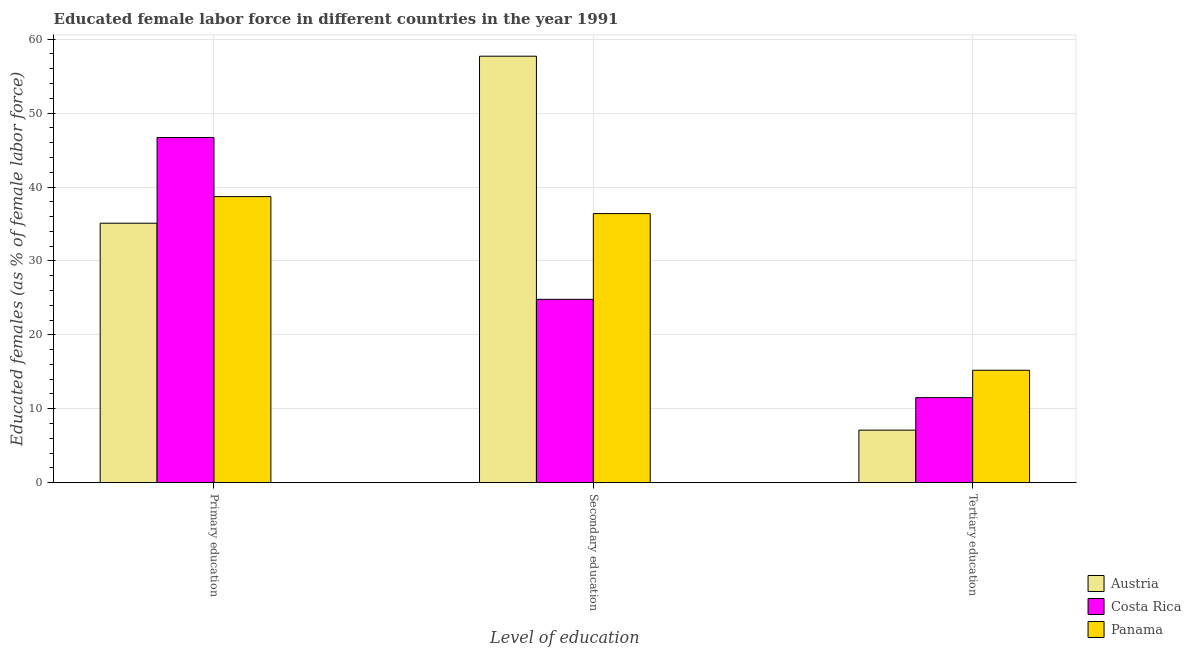How many different coloured bars are there?
Your answer should be very brief. 3. How many groups of bars are there?
Offer a very short reply. 3. Are the number of bars per tick equal to the number of legend labels?
Provide a succinct answer. Yes. Are the number of bars on each tick of the X-axis equal?
Ensure brevity in your answer.  Yes. How many bars are there on the 3rd tick from the right?
Keep it short and to the point. 3. What is the label of the 1st group of bars from the left?
Give a very brief answer. Primary education. What is the percentage of female labor force who received secondary education in Austria?
Ensure brevity in your answer.  57.7. Across all countries, what is the maximum percentage of female labor force who received secondary education?
Ensure brevity in your answer.  57.7. Across all countries, what is the minimum percentage of female labor force who received primary education?
Make the answer very short. 35.1. In which country was the percentage of female labor force who received secondary education maximum?
Your answer should be compact. Austria. What is the total percentage of female labor force who received tertiary education in the graph?
Your answer should be compact. 33.8. What is the difference between the percentage of female labor force who received secondary education in Panama and that in Austria?
Ensure brevity in your answer.  -21.3. What is the difference between the percentage of female labor force who received tertiary education in Austria and the percentage of female labor force who received primary education in Panama?
Offer a terse response. -31.6. What is the average percentage of female labor force who received primary education per country?
Make the answer very short. 40.17. What is the difference between the percentage of female labor force who received tertiary education and percentage of female labor force who received secondary education in Costa Rica?
Give a very brief answer. -13.3. In how many countries, is the percentage of female labor force who received primary education greater than 54 %?
Your response must be concise. 0. What is the ratio of the percentage of female labor force who received primary education in Austria to that in Costa Rica?
Offer a terse response. 0.75. What is the difference between the highest and the second highest percentage of female labor force who received secondary education?
Provide a short and direct response. 21.3. What is the difference between the highest and the lowest percentage of female labor force who received secondary education?
Make the answer very short. 32.9. What does the 1st bar from the right in Primary education represents?
Give a very brief answer. Panama. Are the values on the major ticks of Y-axis written in scientific E-notation?
Your response must be concise. No. Does the graph contain grids?
Provide a short and direct response. Yes. Where does the legend appear in the graph?
Your answer should be very brief. Bottom right. How are the legend labels stacked?
Give a very brief answer. Vertical. What is the title of the graph?
Give a very brief answer. Educated female labor force in different countries in the year 1991. What is the label or title of the X-axis?
Give a very brief answer. Level of education. What is the label or title of the Y-axis?
Give a very brief answer. Educated females (as % of female labor force). What is the Educated females (as % of female labor force) of Austria in Primary education?
Ensure brevity in your answer.  35.1. What is the Educated females (as % of female labor force) in Costa Rica in Primary education?
Provide a short and direct response. 46.7. What is the Educated females (as % of female labor force) of Panama in Primary education?
Keep it short and to the point. 38.7. What is the Educated females (as % of female labor force) in Austria in Secondary education?
Provide a succinct answer. 57.7. What is the Educated females (as % of female labor force) in Costa Rica in Secondary education?
Offer a terse response. 24.8. What is the Educated females (as % of female labor force) of Panama in Secondary education?
Provide a short and direct response. 36.4. What is the Educated females (as % of female labor force) in Austria in Tertiary education?
Provide a succinct answer. 7.1. What is the Educated females (as % of female labor force) of Panama in Tertiary education?
Ensure brevity in your answer.  15.2. Across all Level of education, what is the maximum Educated females (as % of female labor force) in Austria?
Ensure brevity in your answer.  57.7. Across all Level of education, what is the maximum Educated females (as % of female labor force) of Costa Rica?
Ensure brevity in your answer.  46.7. Across all Level of education, what is the maximum Educated females (as % of female labor force) of Panama?
Give a very brief answer. 38.7. Across all Level of education, what is the minimum Educated females (as % of female labor force) of Austria?
Your answer should be compact. 7.1. Across all Level of education, what is the minimum Educated females (as % of female labor force) of Costa Rica?
Ensure brevity in your answer.  11.5. Across all Level of education, what is the minimum Educated females (as % of female labor force) of Panama?
Your answer should be very brief. 15.2. What is the total Educated females (as % of female labor force) of Austria in the graph?
Ensure brevity in your answer.  99.9. What is the total Educated females (as % of female labor force) of Panama in the graph?
Provide a short and direct response. 90.3. What is the difference between the Educated females (as % of female labor force) of Austria in Primary education and that in Secondary education?
Ensure brevity in your answer.  -22.6. What is the difference between the Educated females (as % of female labor force) of Costa Rica in Primary education and that in Secondary education?
Provide a succinct answer. 21.9. What is the difference between the Educated females (as % of female labor force) of Panama in Primary education and that in Secondary education?
Offer a terse response. 2.3. What is the difference between the Educated females (as % of female labor force) in Costa Rica in Primary education and that in Tertiary education?
Offer a very short reply. 35.2. What is the difference between the Educated females (as % of female labor force) in Panama in Primary education and that in Tertiary education?
Ensure brevity in your answer.  23.5. What is the difference between the Educated females (as % of female labor force) of Austria in Secondary education and that in Tertiary education?
Your response must be concise. 50.6. What is the difference between the Educated females (as % of female labor force) of Costa Rica in Secondary education and that in Tertiary education?
Provide a succinct answer. 13.3. What is the difference between the Educated females (as % of female labor force) in Panama in Secondary education and that in Tertiary education?
Provide a succinct answer. 21.2. What is the difference between the Educated females (as % of female labor force) of Austria in Primary education and the Educated females (as % of female labor force) of Costa Rica in Secondary education?
Offer a very short reply. 10.3. What is the difference between the Educated females (as % of female labor force) of Austria in Primary education and the Educated females (as % of female labor force) of Costa Rica in Tertiary education?
Provide a succinct answer. 23.6. What is the difference between the Educated females (as % of female labor force) of Costa Rica in Primary education and the Educated females (as % of female labor force) of Panama in Tertiary education?
Give a very brief answer. 31.5. What is the difference between the Educated females (as % of female labor force) in Austria in Secondary education and the Educated females (as % of female labor force) in Costa Rica in Tertiary education?
Your answer should be very brief. 46.2. What is the difference between the Educated females (as % of female labor force) of Austria in Secondary education and the Educated females (as % of female labor force) of Panama in Tertiary education?
Offer a terse response. 42.5. What is the average Educated females (as % of female labor force) in Austria per Level of education?
Ensure brevity in your answer.  33.3. What is the average Educated females (as % of female labor force) in Costa Rica per Level of education?
Provide a short and direct response. 27.67. What is the average Educated females (as % of female labor force) of Panama per Level of education?
Provide a succinct answer. 30.1. What is the difference between the Educated females (as % of female labor force) of Austria and Educated females (as % of female labor force) of Costa Rica in Primary education?
Your answer should be compact. -11.6. What is the difference between the Educated females (as % of female labor force) in Costa Rica and Educated females (as % of female labor force) in Panama in Primary education?
Offer a terse response. 8. What is the difference between the Educated females (as % of female labor force) in Austria and Educated females (as % of female labor force) in Costa Rica in Secondary education?
Offer a very short reply. 32.9. What is the difference between the Educated females (as % of female labor force) of Austria and Educated females (as % of female labor force) of Panama in Secondary education?
Offer a very short reply. 21.3. What is the difference between the Educated females (as % of female labor force) in Costa Rica and Educated females (as % of female labor force) in Panama in Secondary education?
Your answer should be compact. -11.6. What is the difference between the Educated females (as % of female labor force) in Austria and Educated females (as % of female labor force) in Panama in Tertiary education?
Keep it short and to the point. -8.1. What is the ratio of the Educated females (as % of female labor force) of Austria in Primary education to that in Secondary education?
Offer a very short reply. 0.61. What is the ratio of the Educated females (as % of female labor force) in Costa Rica in Primary education to that in Secondary education?
Your answer should be very brief. 1.88. What is the ratio of the Educated females (as % of female labor force) in Panama in Primary education to that in Secondary education?
Your response must be concise. 1.06. What is the ratio of the Educated females (as % of female labor force) of Austria in Primary education to that in Tertiary education?
Your answer should be compact. 4.94. What is the ratio of the Educated females (as % of female labor force) in Costa Rica in Primary education to that in Tertiary education?
Give a very brief answer. 4.06. What is the ratio of the Educated females (as % of female labor force) in Panama in Primary education to that in Tertiary education?
Your response must be concise. 2.55. What is the ratio of the Educated females (as % of female labor force) of Austria in Secondary education to that in Tertiary education?
Make the answer very short. 8.13. What is the ratio of the Educated females (as % of female labor force) of Costa Rica in Secondary education to that in Tertiary education?
Provide a short and direct response. 2.16. What is the ratio of the Educated females (as % of female labor force) of Panama in Secondary education to that in Tertiary education?
Your response must be concise. 2.39. What is the difference between the highest and the second highest Educated females (as % of female labor force) of Austria?
Provide a succinct answer. 22.6. What is the difference between the highest and the second highest Educated females (as % of female labor force) in Costa Rica?
Your response must be concise. 21.9. What is the difference between the highest and the lowest Educated females (as % of female labor force) of Austria?
Your answer should be very brief. 50.6. What is the difference between the highest and the lowest Educated females (as % of female labor force) in Costa Rica?
Provide a short and direct response. 35.2. 